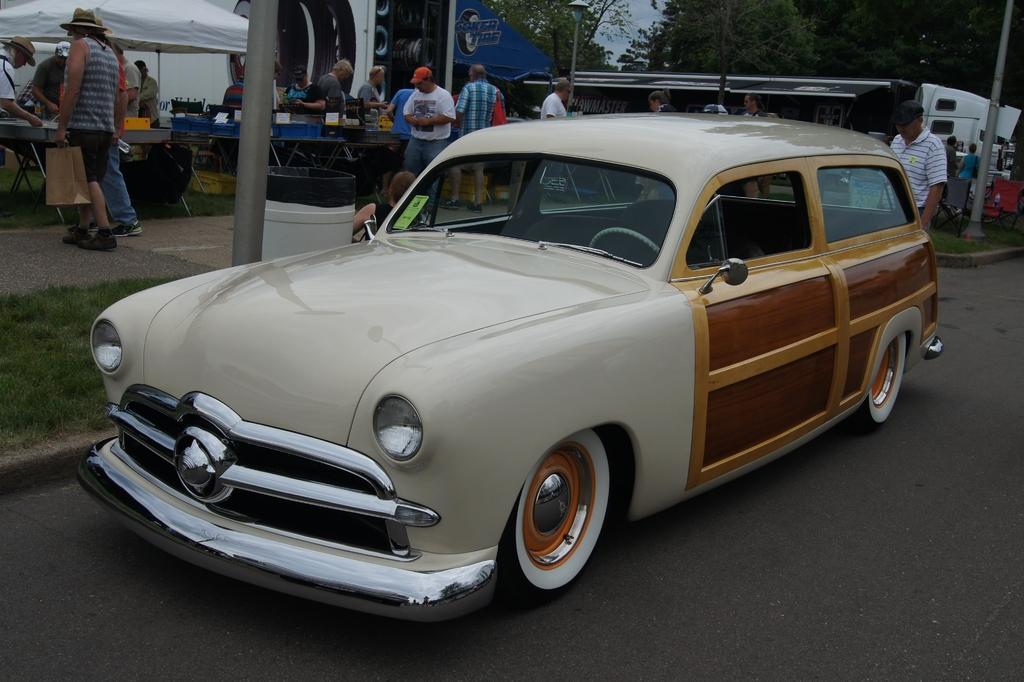Please provide a concise description of this image. In this image there is a car on road, in the background there are food quotes, people are doing different activities, on the right side there are trees. 